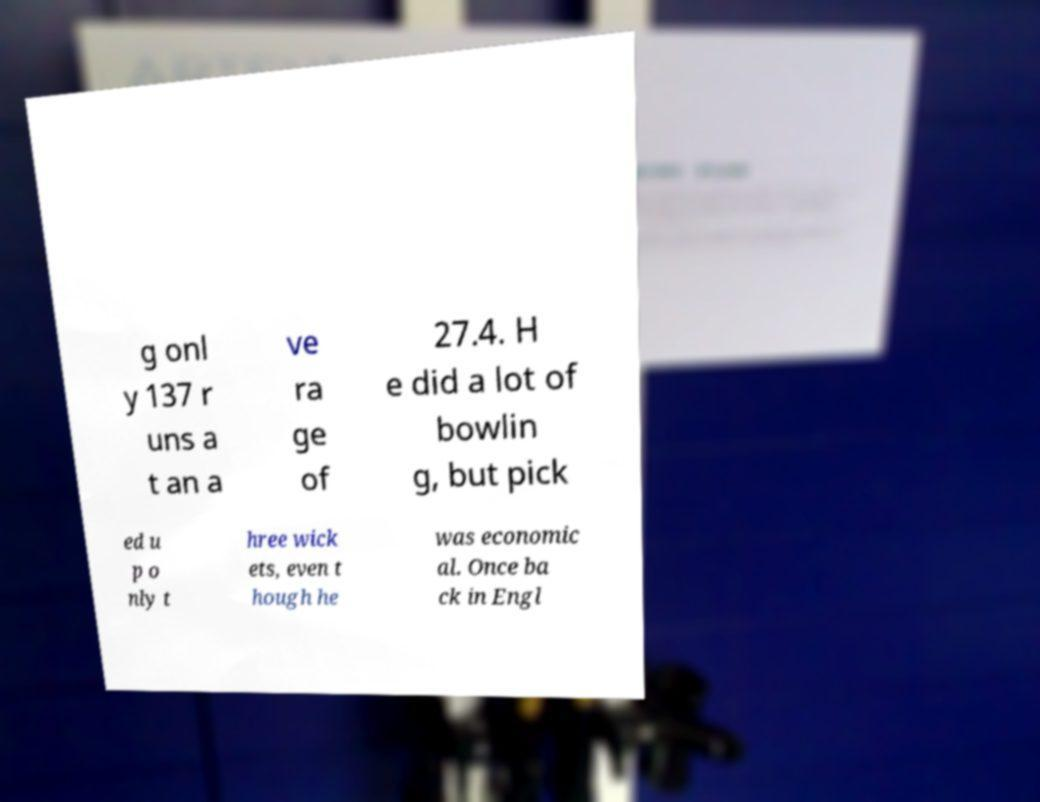There's text embedded in this image that I need extracted. Can you transcribe it verbatim? g onl y 137 r uns a t an a ve ra ge of 27.4. H e did a lot of bowlin g, but pick ed u p o nly t hree wick ets, even t hough he was economic al. Once ba ck in Engl 